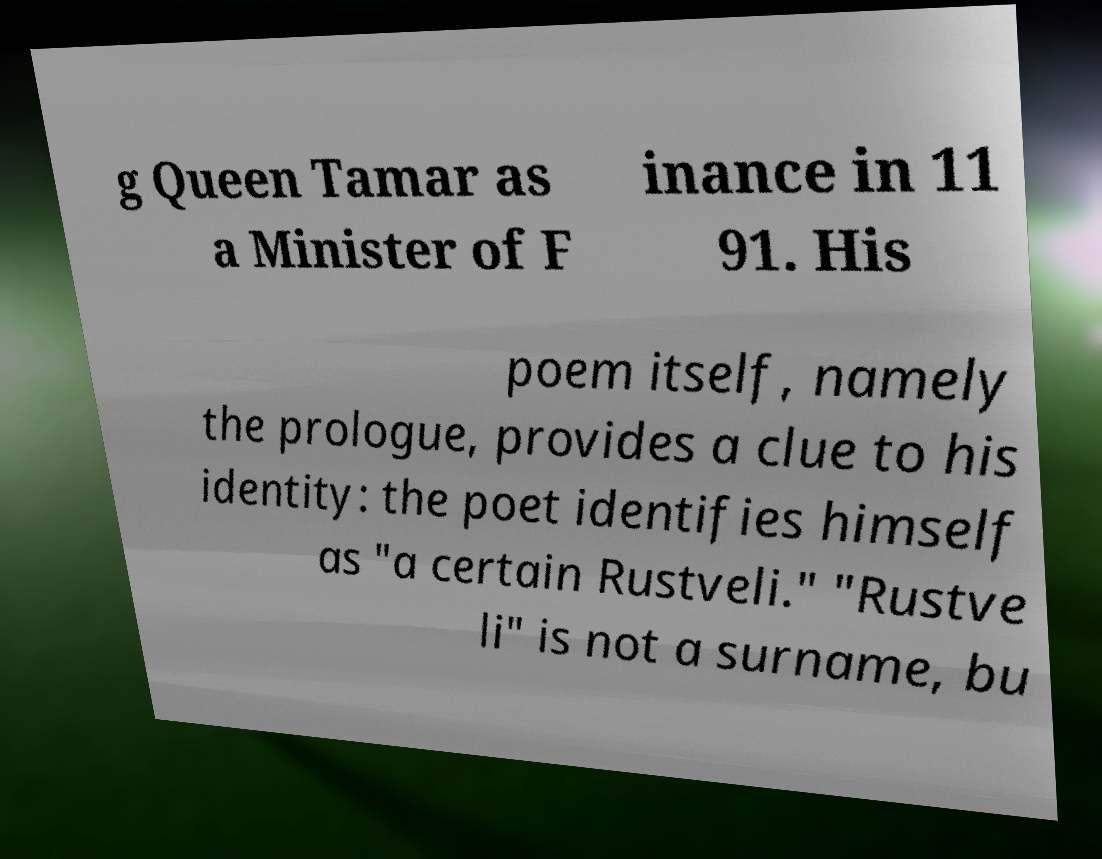What messages or text are displayed in this image? I need them in a readable, typed format. g Queen Tamar as a Minister of F inance in 11 91. His poem itself, namely the prologue, provides a clue to his identity: the poet identifies himself as "a certain Rustveli." "Rustve li" is not a surname, bu 